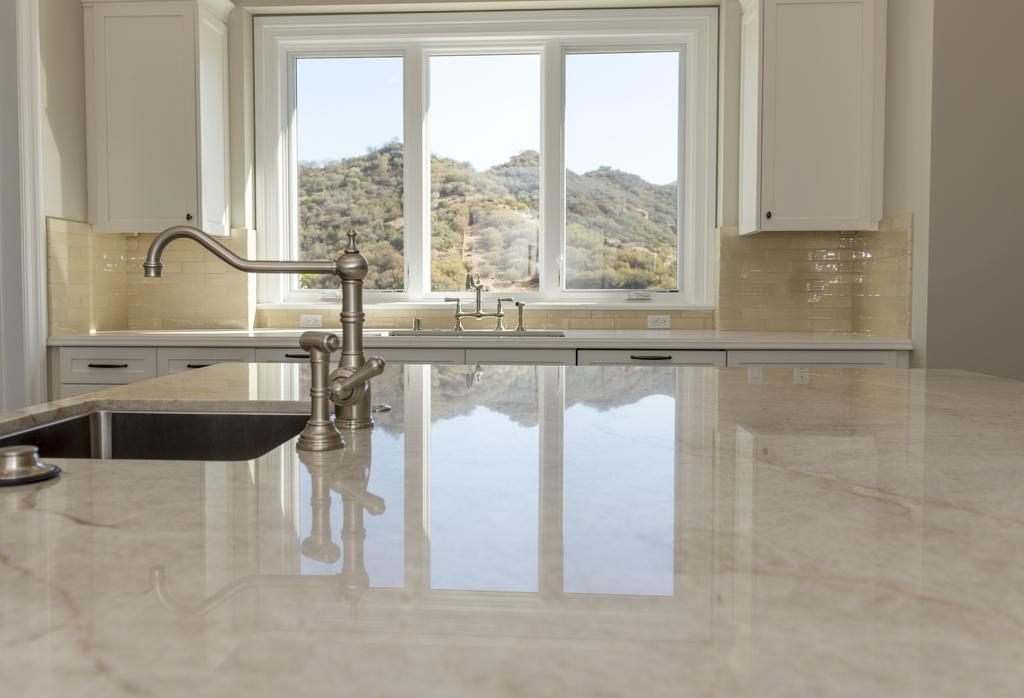What type of surface is present in the image? There are kitchen tops in the image. What features are present on the kitchen tops? The kitchen tops have sinks and taps. What can be seen in the background of the image? There are cupboards, windows, trees, the sky, and other unspecified objects in the background of the image. What type of collar is visible on the trees in the image? There are no collars present on the trees in the image; they are natural trees. What type of magic is being performed in the image? There is no magic being performed in the image; it is a realistic scene of a kitchen and its surroundings. 